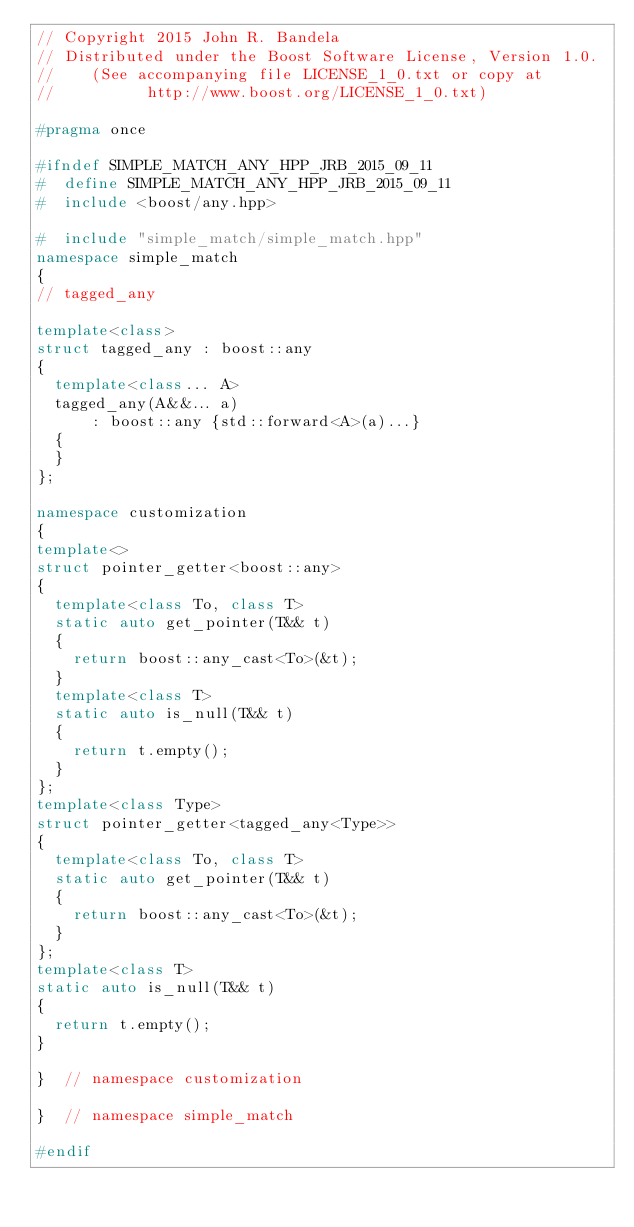Convert code to text. <code><loc_0><loc_0><loc_500><loc_500><_C++_>// Copyright 2015 John R. Bandela
// Distributed under the Boost Software License, Version 1.0.
//    (See accompanying file LICENSE_1_0.txt or copy at
//          http://www.boost.org/LICENSE_1_0.txt)

#pragma once

#ifndef SIMPLE_MATCH_ANY_HPP_JRB_2015_09_11
#  define SIMPLE_MATCH_ANY_HPP_JRB_2015_09_11
#  include <boost/any.hpp>

#  include "simple_match/simple_match.hpp"
namespace simple_match
{
// tagged_any

template<class>
struct tagged_any : boost::any
{
  template<class... A>
  tagged_any(A&&... a)
      : boost::any {std::forward<A>(a)...}
  {
  }
};

namespace customization
{
template<>
struct pointer_getter<boost::any>
{
  template<class To, class T>
  static auto get_pointer(T&& t)
  {
    return boost::any_cast<To>(&t);
  }
  template<class T>
  static auto is_null(T&& t)
  {
    return t.empty();
  }
};
template<class Type>
struct pointer_getter<tagged_any<Type>>
{
  template<class To, class T>
  static auto get_pointer(T&& t)
  {
    return boost::any_cast<To>(&t);
  }
};
template<class T>
static auto is_null(T&& t)
{
  return t.empty();
}

}  // namespace customization

}  // namespace simple_match

#endif
</code> 